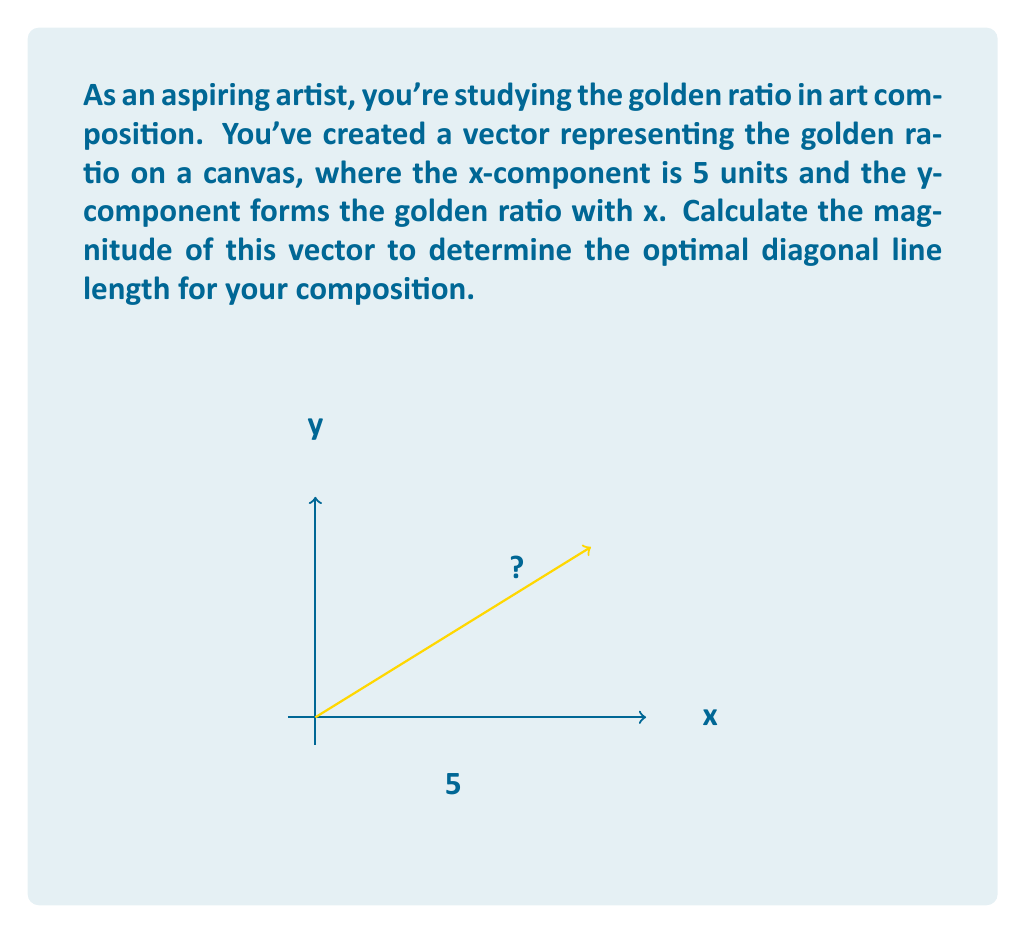Help me with this question. Let's approach this step-by-step:

1) The golden ratio, often denoted by φ (phi), is approximately 1.618033988749895.

2) Given that the x-component is 5 units, the y-component will be:
   $y = 5 \div \phi \approx 5 \div 1.618033988749895 \approx 3.09016994375$

3) Now we have a vector with components (5, 3.09016994375).

4) To find the magnitude of a vector, we use the formula:
   $\text{magnitude} = \sqrt{x^2 + y^2}$

5) Substituting our values:
   $\text{magnitude} = \sqrt{5^2 + 3.09016994375^2}$

6) Simplifying:
   $\text{magnitude} = \sqrt{25 + 9.54915028125}$
   $\text{magnitude} = \sqrt{34.54915028125}$

7) Taking the square root:
   $\text{magnitude} \approx 5.87785252292$

Therefore, the magnitude of the vector representing the golden ratio in your art composition is approximately 5.88 units.
Answer: $5.88$ units 